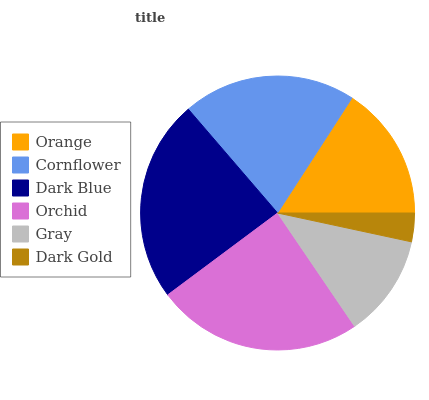Is Dark Gold the minimum?
Answer yes or no. Yes. Is Orchid the maximum?
Answer yes or no. Yes. Is Cornflower the minimum?
Answer yes or no. No. Is Cornflower the maximum?
Answer yes or no. No. Is Cornflower greater than Orange?
Answer yes or no. Yes. Is Orange less than Cornflower?
Answer yes or no. Yes. Is Orange greater than Cornflower?
Answer yes or no. No. Is Cornflower less than Orange?
Answer yes or no. No. Is Cornflower the high median?
Answer yes or no. Yes. Is Orange the low median?
Answer yes or no. Yes. Is Dark Gold the high median?
Answer yes or no. No. Is Dark Gold the low median?
Answer yes or no. No. 